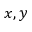<formula> <loc_0><loc_0><loc_500><loc_500>x , y</formula> 